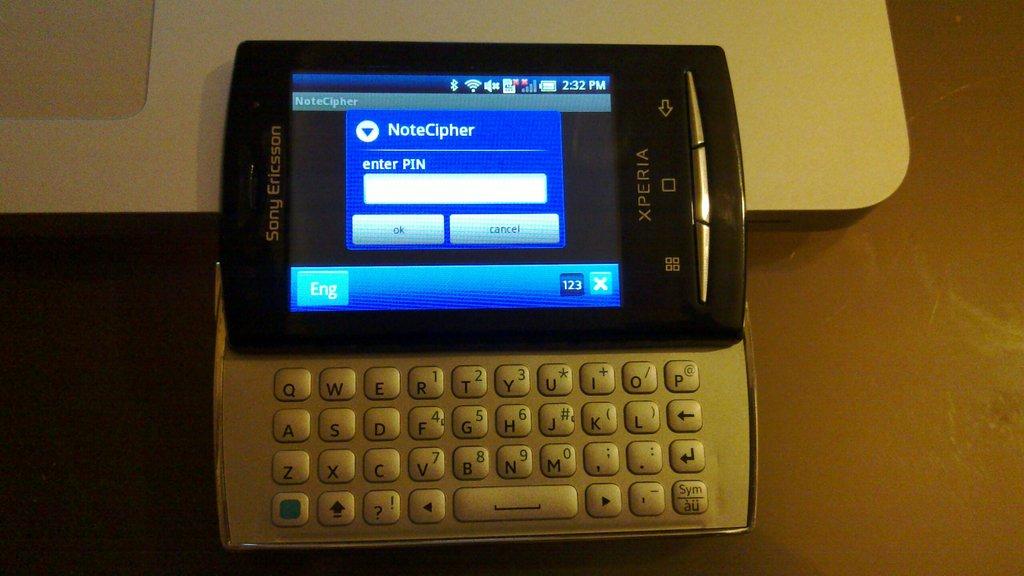What model of phone is this?
Provide a short and direct response. Xperia. Can you enter your pin here?
Give a very brief answer. Yes. 